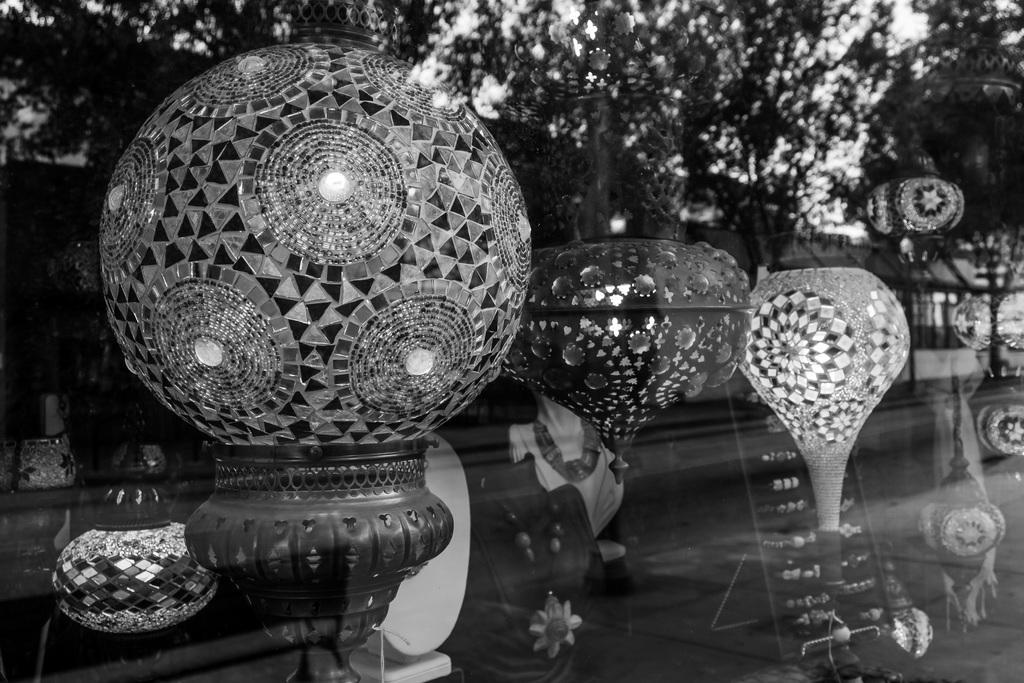In one or two sentences, can you explain what this image depicts? In this image there is a glass through which we can see there are some glowing decorative items and a few other items and we can see the reflection of the trees in the glass. 